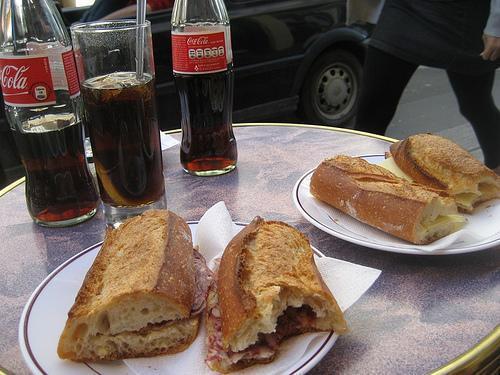How many cola bottles are there?
Give a very brief answer. 2. How many bottles are there?
Give a very brief answer. 2. How many sandwiches are there?
Give a very brief answer. 4. 